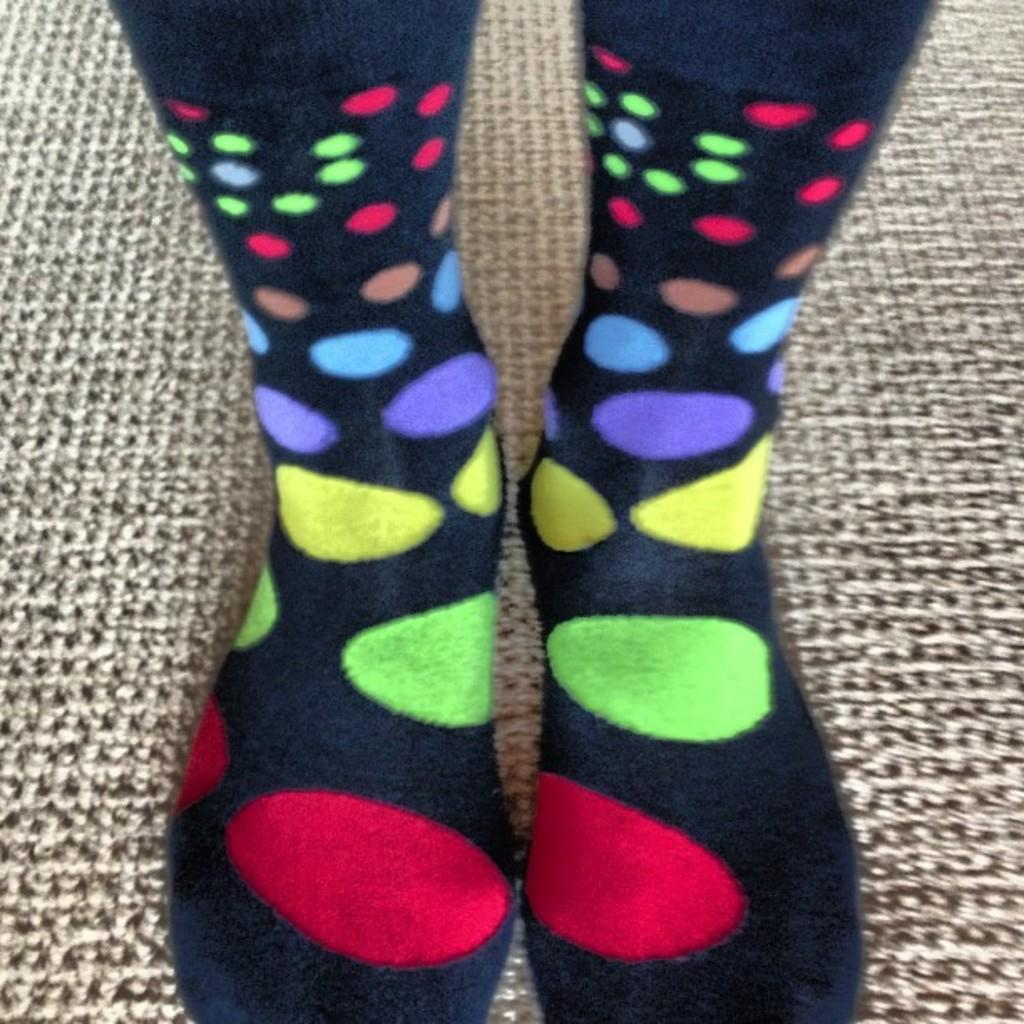What is the main subject of the image? There is a person in the image. What part of the person's body can be seen? The person's legs are visible. What are the person's legs wearing? The person's legs are wearing socks. What is the person's posture in the image? The person is standing. What is the surface behind the person? The background appears to be a mat. What type of hydrant is visible in the image? There is no hydrant present in the image. How does the person slip on the mat in the image? The person does not slip on the mat in the image; they are standing. 